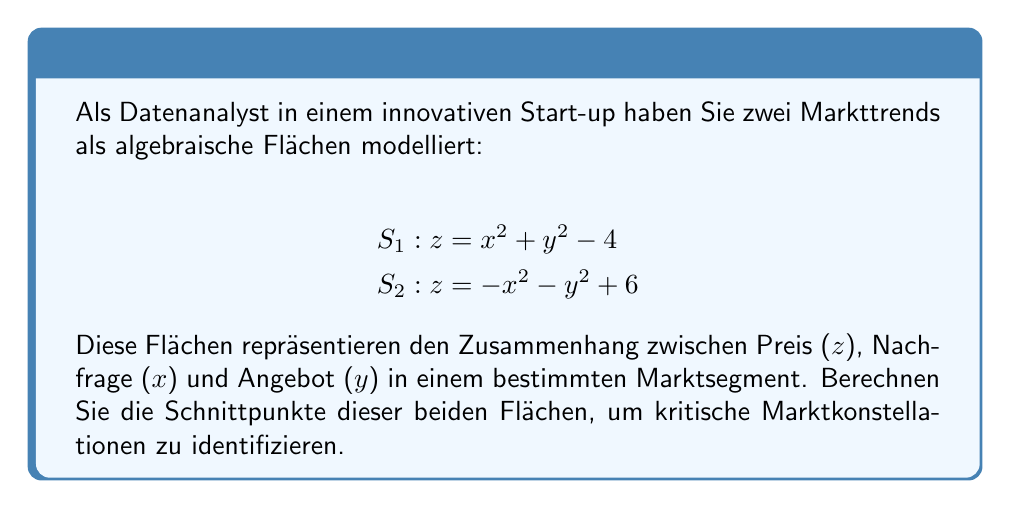Provide a solution to this math problem. Um die Schnittpunkte zu finden, setzen wir die beiden Gleichungen gleich:

$$x^2 + y^2 - 4 = -x^2 - y^2 + 6$$

Nun lösen wir diese Gleichung Schritt für Schritt:

1) Addieren wir $x^2 + y^2$ auf beiden Seiten:
   $$2x^2 + 2y^2 - 4 = 6$$

2) Addieren wir 4 auf beiden Seiten:
   $$2x^2 + 2y^2 = 10$$

3) Dividieren wir durch 2:
   $$x^2 + y^2 = 5$$

Dies ist die Gleichung eines Kreises mit Radius $\sqrt{5}$ in der xy-Ebene.

4) Um die z-Koordinate zu finden, setzen wir diese Gleichung in eine der ursprünglichen Gleichungen ein, z.B. in $S_1$:

   $$z = x^2 + y^2 - 4 = 5 - 4 = 1$$

5) Nun müssen wir die x- und y-Koordinaten finden. Da wir einen Kreis in der xy-Ebene haben, können wir die Gleichung in Polarkoordinaten umschreiben:

   $$x = \sqrt{5} \cos(\theta)$$
   $$y = \sqrt{5} \sin(\theta)$$

6) Die Schnittpunkte sind also:

   $$(\sqrt{5} \cos(\theta), \sqrt{5} \sin(\theta), 1)$$

   für alle Werte von $\theta$ zwischen 0 und $2\pi$.
Answer: $(\sqrt{5} \cos(\theta), \sqrt{5} \sin(\theta), 1)$, $0 \leq \theta < 2\pi$ 